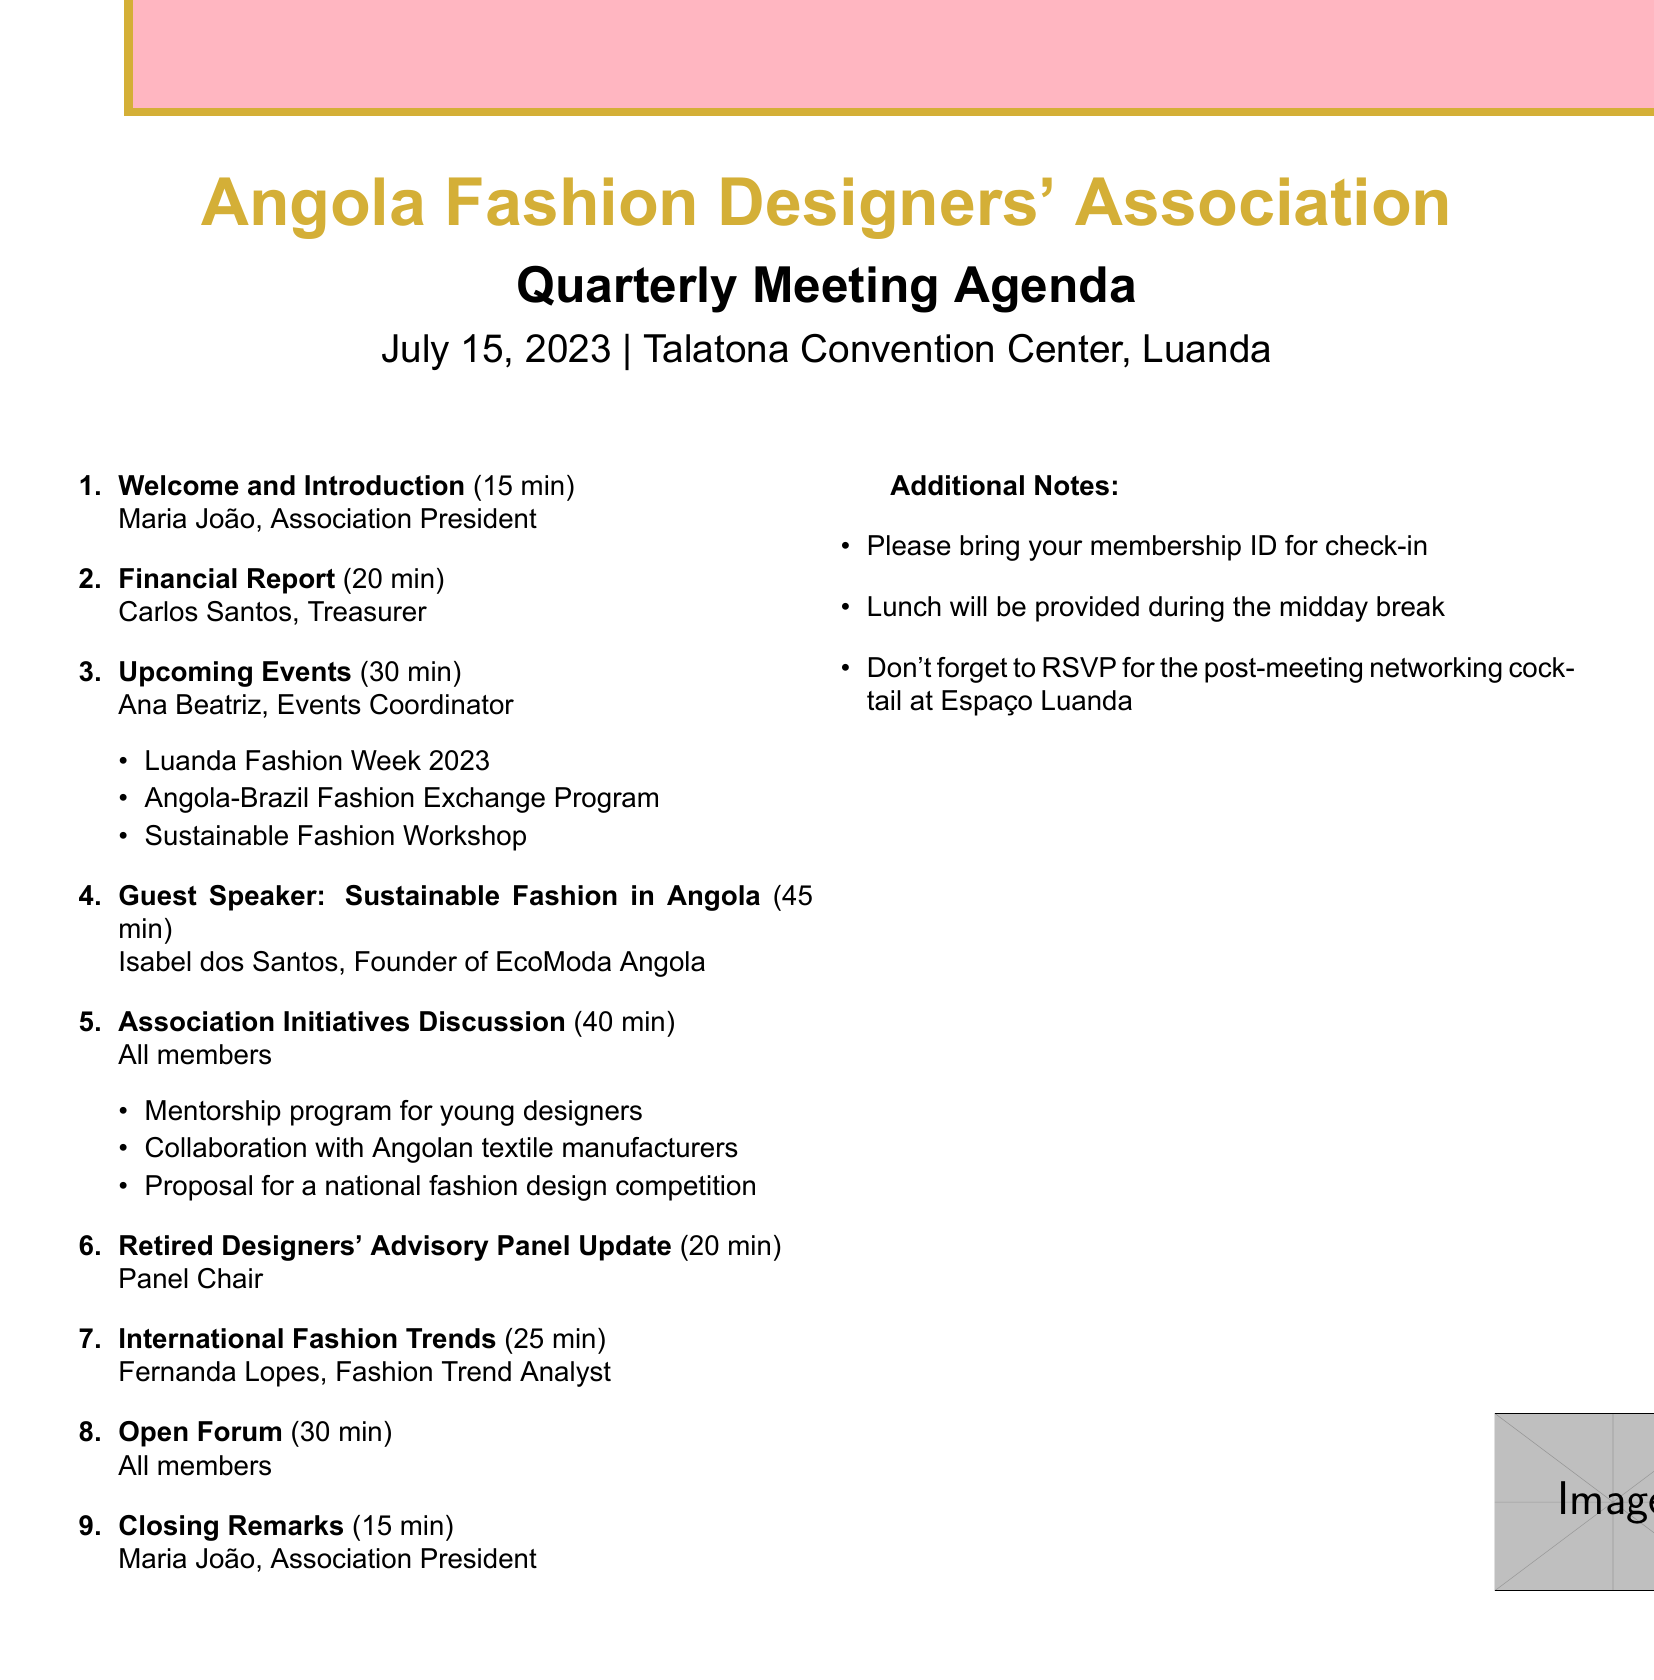What is the title of the meeting? The title of the meeting is stated at the beginning of the agenda.
Answer: Angola Fashion Designers' Association Quarterly Meeting Who is the presenter for the Financial Report? The presenter is listed alongside the agenda item for the financial report.
Answer: Carlos Santos What is the date of the meeting? The date is included in the header of the agenda.
Answer: July 15, 2023 How long will the Guest Speaker presentation last? The duration for the guest speaker session is specified in the agenda item.
Answer: 45 minutes What is one of the upcoming events mentioned? The agenda lists specific upcoming events as part of an agenda item.
Answer: Luanda Fashion Week 2023 Who is the guest speaker at the meeting? The guest speaker's name is provided in the specific agenda item.
Answer: Isabel dos Santos How many minutes are allocated for the 'Open Forum' discussion? The duration for the open forum is explicitly mentioned in the agenda.
Answer: 30 minutes What is one of the additional notes for attendees? Additional notes provide specific instructions for attendees and can be found at the end of the agenda.
Answer: Please bring your membership ID for check-in Which association initiative will be discussed? The discussion of initiatives is included in one of the agenda items.
Answer: Mentorship program for young designers 